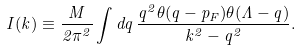Convert formula to latex. <formula><loc_0><loc_0><loc_500><loc_500>I ( k ) \equiv \frac { M } { 2 \pi ^ { 2 } } \int d q \, \frac { q ^ { 2 } \theta ( q - p _ { F } ) \theta ( \Lambda - q ) } { { k ^ { 2 } } - { q ^ { 2 } } } .</formula> 